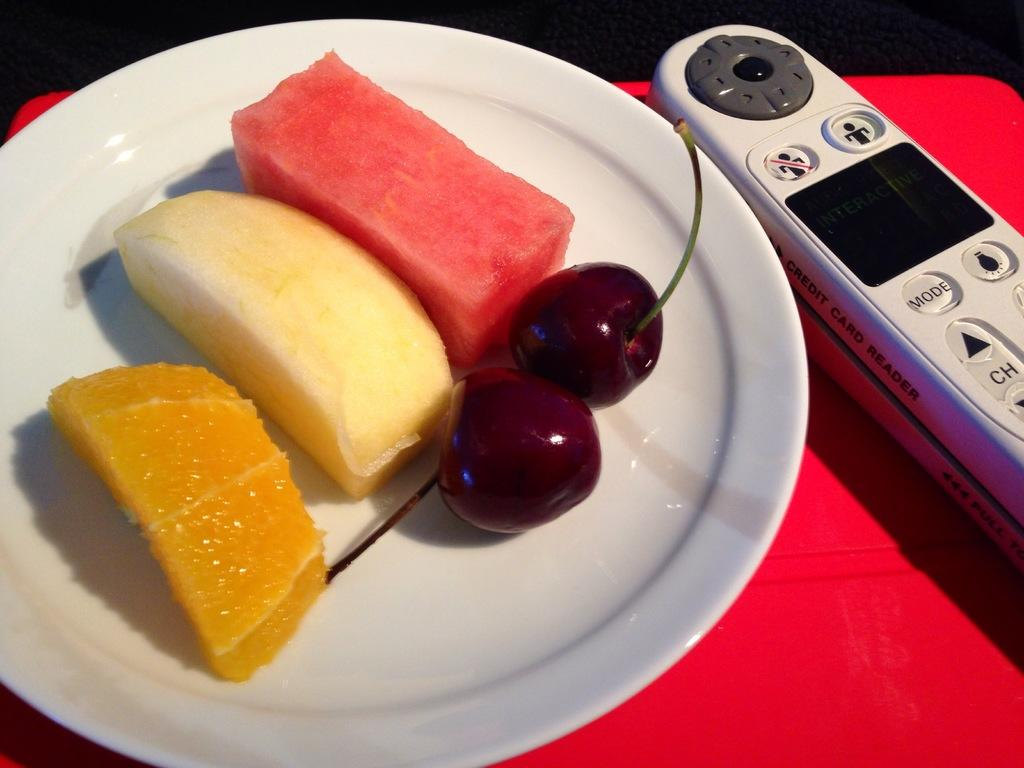<image>
Give a short and clear explanation of the subsequent image. remote with mode button beside plate of fruit. 